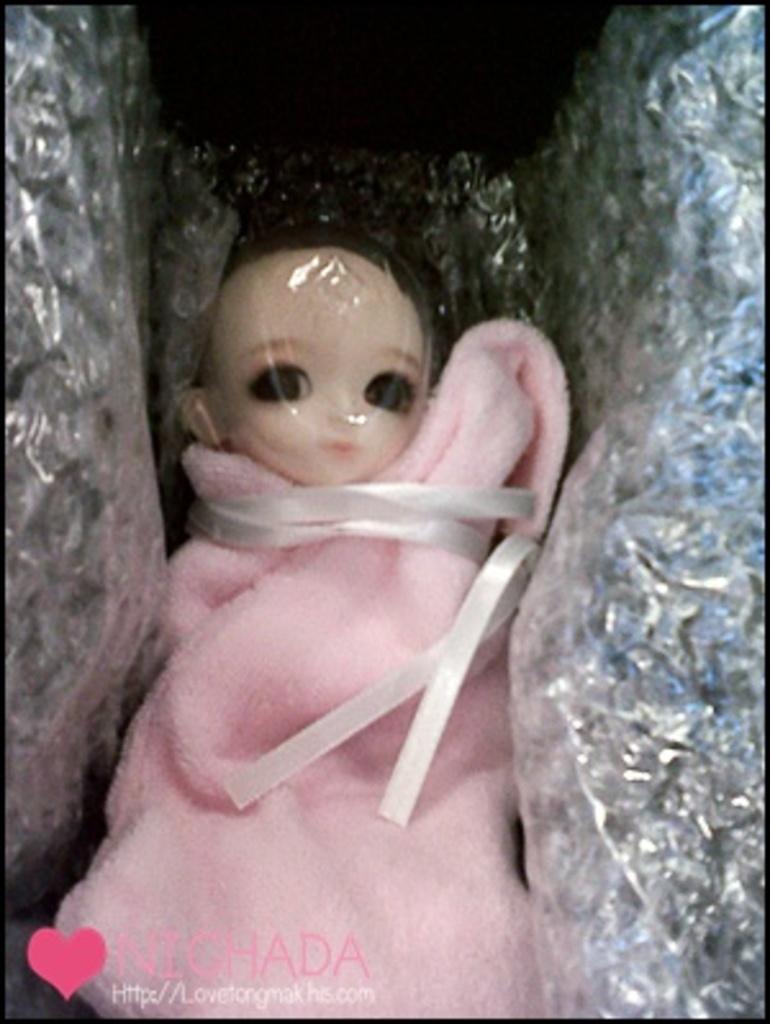How would you summarize this image in a sentence or two? In this image I can see a doll wrapped with pink cloth and a cover. 